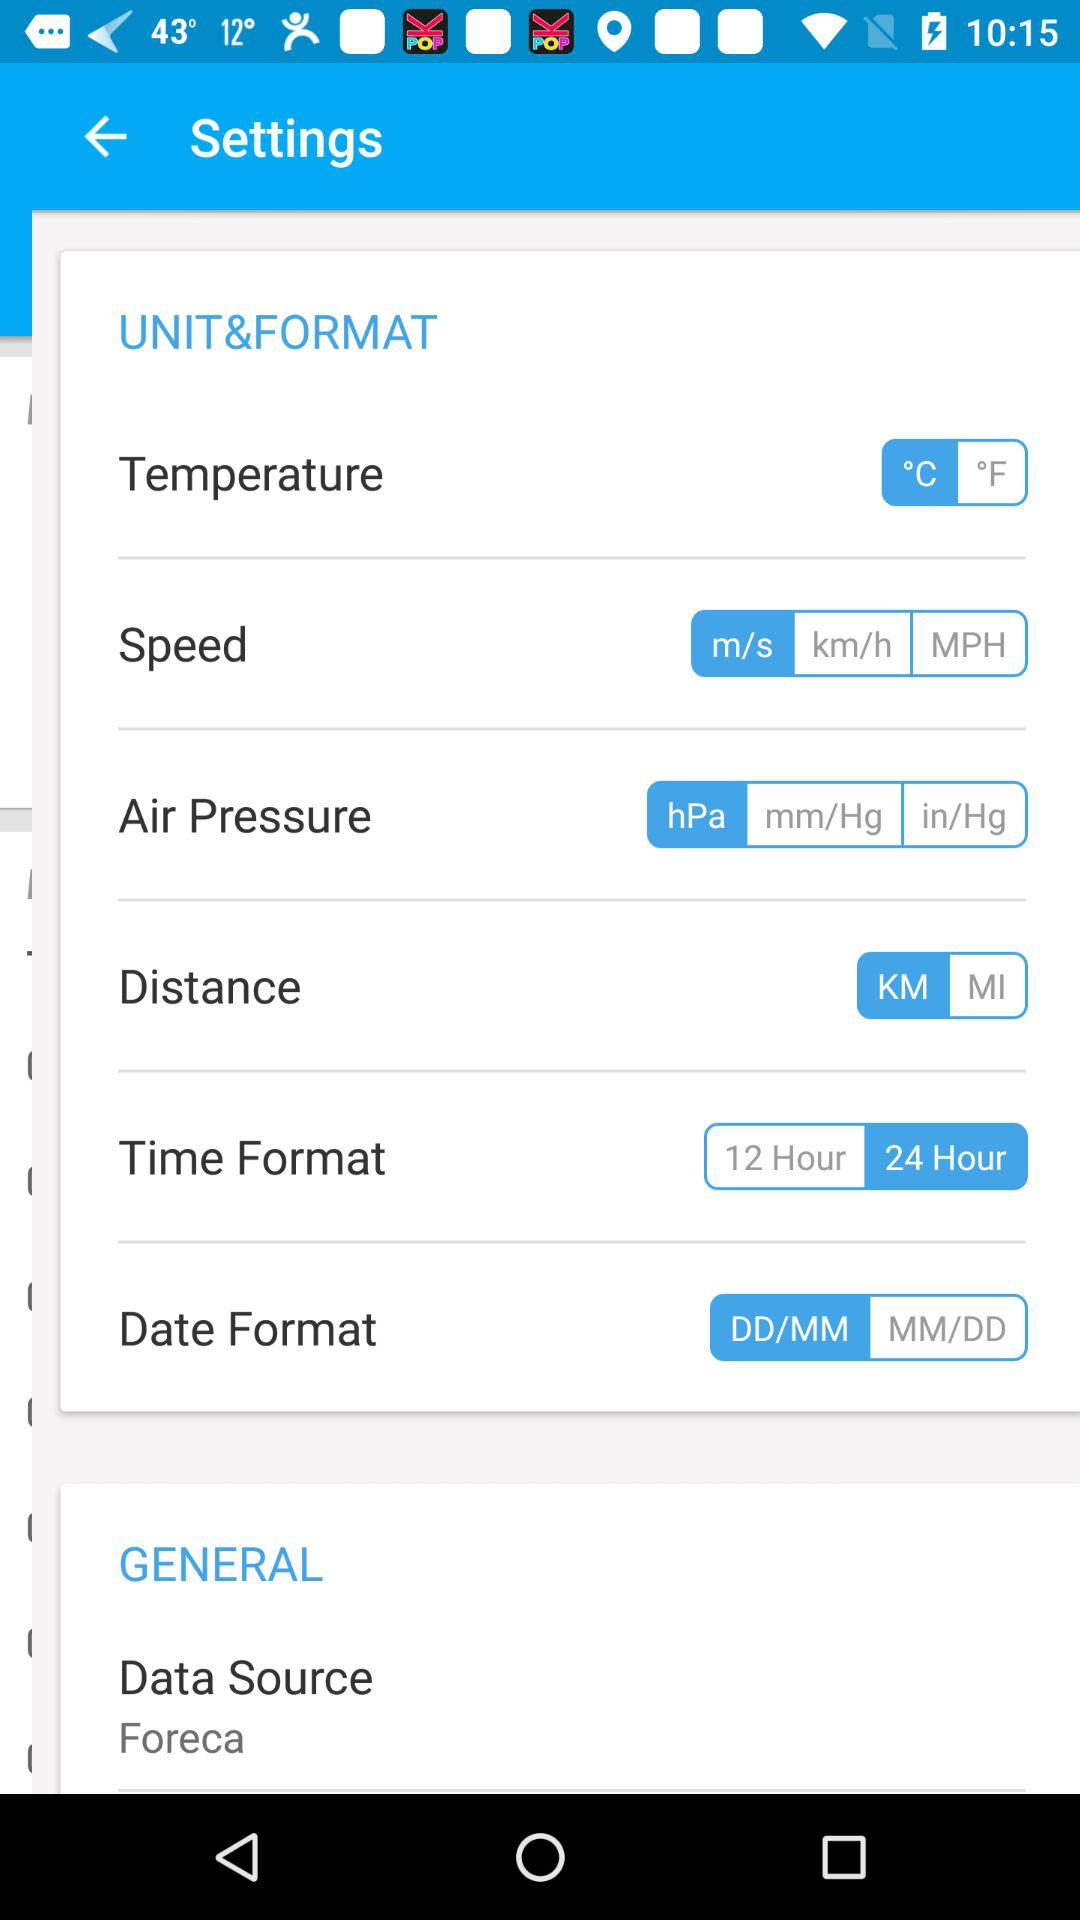Which distance unit is selected? The selected distance unit is KM. 